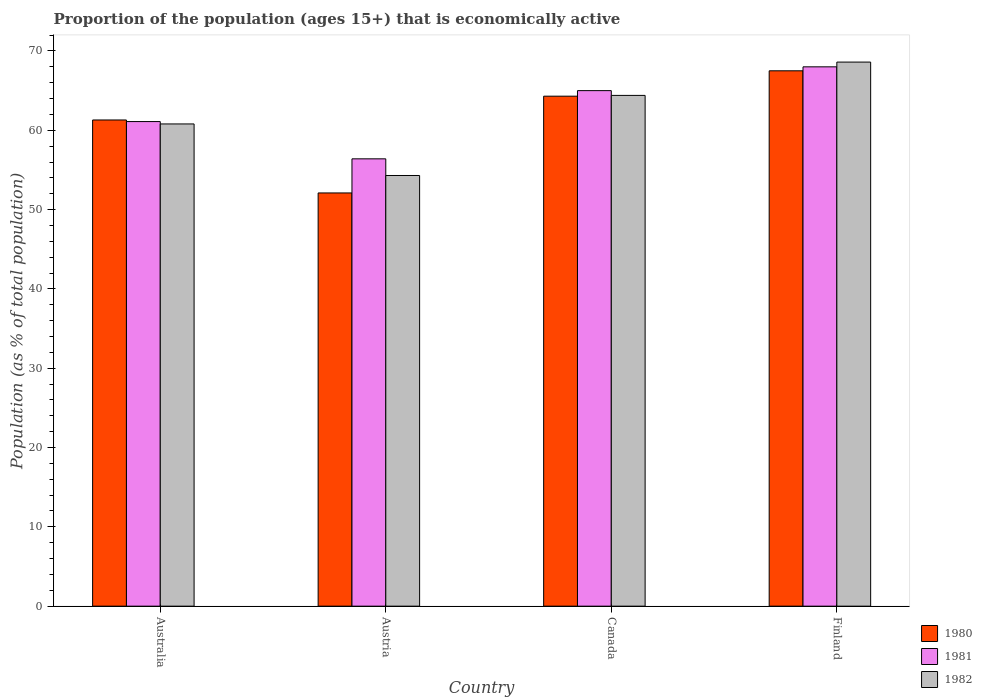How many groups of bars are there?
Provide a succinct answer. 4. Are the number of bars per tick equal to the number of legend labels?
Provide a succinct answer. Yes. What is the proportion of the population that is economically active in 1982 in Australia?
Your answer should be very brief. 60.8. Across all countries, what is the maximum proportion of the population that is economically active in 1980?
Your response must be concise. 67.5. Across all countries, what is the minimum proportion of the population that is economically active in 1980?
Give a very brief answer. 52.1. In which country was the proportion of the population that is economically active in 1980 minimum?
Keep it short and to the point. Austria. What is the total proportion of the population that is economically active in 1981 in the graph?
Your answer should be very brief. 250.5. What is the difference between the proportion of the population that is economically active in 1982 in Australia and that in Canada?
Keep it short and to the point. -3.6. What is the difference between the proportion of the population that is economically active in 1980 in Finland and the proportion of the population that is economically active in 1982 in Australia?
Your response must be concise. 6.7. What is the average proportion of the population that is economically active in 1980 per country?
Provide a short and direct response. 61.3. What is the difference between the proportion of the population that is economically active of/in 1982 and proportion of the population that is economically active of/in 1980 in Canada?
Offer a very short reply. 0.1. What is the ratio of the proportion of the population that is economically active in 1982 in Austria to that in Finland?
Make the answer very short. 0.79. Is the difference between the proportion of the population that is economically active in 1982 in Canada and Finland greater than the difference between the proportion of the population that is economically active in 1980 in Canada and Finland?
Your answer should be compact. No. What is the difference between the highest and the second highest proportion of the population that is economically active in 1980?
Give a very brief answer. -3.2. What is the difference between the highest and the lowest proportion of the population that is economically active in 1982?
Your answer should be compact. 14.3. In how many countries, is the proportion of the population that is economically active in 1981 greater than the average proportion of the population that is economically active in 1981 taken over all countries?
Keep it short and to the point. 2. What does the 2nd bar from the right in Australia represents?
Offer a very short reply. 1981. How many bars are there?
Your answer should be very brief. 12. Are the values on the major ticks of Y-axis written in scientific E-notation?
Keep it short and to the point. No. Does the graph contain grids?
Make the answer very short. No. How many legend labels are there?
Make the answer very short. 3. How are the legend labels stacked?
Give a very brief answer. Vertical. What is the title of the graph?
Offer a terse response. Proportion of the population (ages 15+) that is economically active. Does "2006" appear as one of the legend labels in the graph?
Give a very brief answer. No. What is the label or title of the X-axis?
Your answer should be compact. Country. What is the label or title of the Y-axis?
Offer a terse response. Population (as % of total population). What is the Population (as % of total population) of 1980 in Australia?
Make the answer very short. 61.3. What is the Population (as % of total population) in 1981 in Australia?
Your answer should be compact. 61.1. What is the Population (as % of total population) of 1982 in Australia?
Make the answer very short. 60.8. What is the Population (as % of total population) in 1980 in Austria?
Offer a very short reply. 52.1. What is the Population (as % of total population) of 1981 in Austria?
Provide a succinct answer. 56.4. What is the Population (as % of total population) in 1982 in Austria?
Keep it short and to the point. 54.3. What is the Population (as % of total population) of 1980 in Canada?
Your answer should be compact. 64.3. What is the Population (as % of total population) in 1982 in Canada?
Keep it short and to the point. 64.4. What is the Population (as % of total population) of 1980 in Finland?
Ensure brevity in your answer.  67.5. What is the Population (as % of total population) of 1982 in Finland?
Provide a succinct answer. 68.6. Across all countries, what is the maximum Population (as % of total population) of 1980?
Provide a short and direct response. 67.5. Across all countries, what is the maximum Population (as % of total population) in 1981?
Your answer should be very brief. 68. Across all countries, what is the maximum Population (as % of total population) of 1982?
Give a very brief answer. 68.6. Across all countries, what is the minimum Population (as % of total population) of 1980?
Offer a very short reply. 52.1. Across all countries, what is the minimum Population (as % of total population) in 1981?
Provide a short and direct response. 56.4. Across all countries, what is the minimum Population (as % of total population) of 1982?
Offer a very short reply. 54.3. What is the total Population (as % of total population) in 1980 in the graph?
Your response must be concise. 245.2. What is the total Population (as % of total population) of 1981 in the graph?
Give a very brief answer. 250.5. What is the total Population (as % of total population) in 1982 in the graph?
Give a very brief answer. 248.1. What is the difference between the Population (as % of total population) of 1980 in Australia and that in Austria?
Offer a terse response. 9.2. What is the difference between the Population (as % of total population) in 1982 in Australia and that in Austria?
Ensure brevity in your answer.  6.5. What is the difference between the Population (as % of total population) in 1982 in Australia and that in Canada?
Make the answer very short. -3.6. What is the difference between the Population (as % of total population) of 1980 in Australia and that in Finland?
Provide a short and direct response. -6.2. What is the difference between the Population (as % of total population) in 1981 in Australia and that in Finland?
Your answer should be very brief. -6.9. What is the difference between the Population (as % of total population) in 1982 in Australia and that in Finland?
Your answer should be compact. -7.8. What is the difference between the Population (as % of total population) of 1980 in Austria and that in Canada?
Give a very brief answer. -12.2. What is the difference between the Population (as % of total population) in 1981 in Austria and that in Canada?
Give a very brief answer. -8.6. What is the difference between the Population (as % of total population) of 1980 in Austria and that in Finland?
Your answer should be compact. -15.4. What is the difference between the Population (as % of total population) in 1981 in Austria and that in Finland?
Offer a terse response. -11.6. What is the difference between the Population (as % of total population) in 1982 in Austria and that in Finland?
Make the answer very short. -14.3. What is the difference between the Population (as % of total population) of 1980 in Australia and the Population (as % of total population) of 1982 in Austria?
Your answer should be compact. 7. What is the difference between the Population (as % of total population) of 1980 in Australia and the Population (as % of total population) of 1981 in Canada?
Ensure brevity in your answer.  -3.7. What is the difference between the Population (as % of total population) of 1980 in Australia and the Population (as % of total population) of 1982 in Canada?
Offer a very short reply. -3.1. What is the difference between the Population (as % of total population) in 1981 in Australia and the Population (as % of total population) in 1982 in Canada?
Offer a terse response. -3.3. What is the difference between the Population (as % of total population) of 1980 in Australia and the Population (as % of total population) of 1982 in Finland?
Your answer should be very brief. -7.3. What is the difference between the Population (as % of total population) in 1981 in Australia and the Population (as % of total population) in 1982 in Finland?
Your answer should be compact. -7.5. What is the difference between the Population (as % of total population) of 1981 in Austria and the Population (as % of total population) of 1982 in Canada?
Provide a succinct answer. -8. What is the difference between the Population (as % of total population) in 1980 in Austria and the Population (as % of total population) in 1981 in Finland?
Provide a succinct answer. -15.9. What is the difference between the Population (as % of total population) of 1980 in Austria and the Population (as % of total population) of 1982 in Finland?
Make the answer very short. -16.5. What is the difference between the Population (as % of total population) in 1981 in Austria and the Population (as % of total population) in 1982 in Finland?
Offer a very short reply. -12.2. What is the difference between the Population (as % of total population) in 1981 in Canada and the Population (as % of total population) in 1982 in Finland?
Your response must be concise. -3.6. What is the average Population (as % of total population) of 1980 per country?
Your answer should be compact. 61.3. What is the average Population (as % of total population) in 1981 per country?
Keep it short and to the point. 62.62. What is the average Population (as % of total population) in 1982 per country?
Offer a terse response. 62.02. What is the difference between the Population (as % of total population) in 1981 and Population (as % of total population) in 1982 in Australia?
Your answer should be compact. 0.3. What is the difference between the Population (as % of total population) of 1980 and Population (as % of total population) of 1982 in Austria?
Provide a short and direct response. -2.2. What is the difference between the Population (as % of total population) in 1980 and Population (as % of total population) in 1982 in Finland?
Your response must be concise. -1.1. What is the ratio of the Population (as % of total population) of 1980 in Australia to that in Austria?
Keep it short and to the point. 1.18. What is the ratio of the Population (as % of total population) in 1981 in Australia to that in Austria?
Provide a short and direct response. 1.08. What is the ratio of the Population (as % of total population) in 1982 in Australia to that in Austria?
Offer a terse response. 1.12. What is the ratio of the Population (as % of total population) of 1980 in Australia to that in Canada?
Make the answer very short. 0.95. What is the ratio of the Population (as % of total population) of 1981 in Australia to that in Canada?
Make the answer very short. 0.94. What is the ratio of the Population (as % of total population) in 1982 in Australia to that in Canada?
Your answer should be compact. 0.94. What is the ratio of the Population (as % of total population) in 1980 in Australia to that in Finland?
Your answer should be compact. 0.91. What is the ratio of the Population (as % of total population) in 1981 in Australia to that in Finland?
Offer a very short reply. 0.9. What is the ratio of the Population (as % of total population) in 1982 in Australia to that in Finland?
Make the answer very short. 0.89. What is the ratio of the Population (as % of total population) of 1980 in Austria to that in Canada?
Your response must be concise. 0.81. What is the ratio of the Population (as % of total population) in 1981 in Austria to that in Canada?
Ensure brevity in your answer.  0.87. What is the ratio of the Population (as % of total population) in 1982 in Austria to that in Canada?
Your answer should be compact. 0.84. What is the ratio of the Population (as % of total population) of 1980 in Austria to that in Finland?
Provide a short and direct response. 0.77. What is the ratio of the Population (as % of total population) in 1981 in Austria to that in Finland?
Make the answer very short. 0.83. What is the ratio of the Population (as % of total population) of 1982 in Austria to that in Finland?
Offer a very short reply. 0.79. What is the ratio of the Population (as % of total population) of 1980 in Canada to that in Finland?
Your response must be concise. 0.95. What is the ratio of the Population (as % of total population) in 1981 in Canada to that in Finland?
Give a very brief answer. 0.96. What is the ratio of the Population (as % of total population) of 1982 in Canada to that in Finland?
Provide a short and direct response. 0.94. What is the difference between the highest and the lowest Population (as % of total population) in 1980?
Offer a terse response. 15.4. 